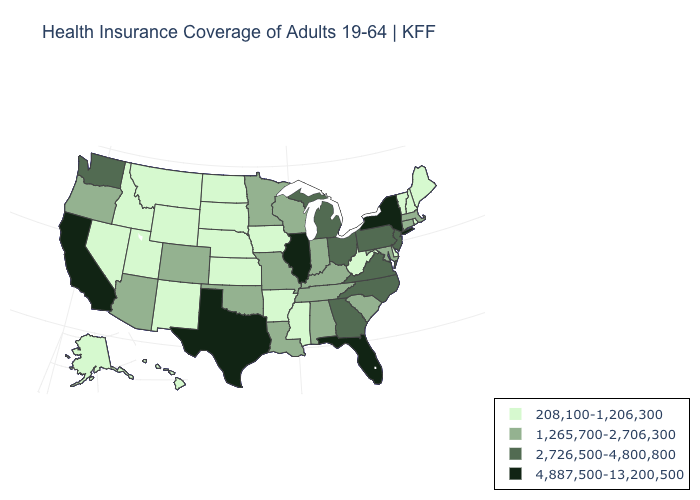Does Michigan have the same value as New Jersey?
Write a very short answer. Yes. What is the value of New Jersey?
Write a very short answer. 2,726,500-4,800,800. Name the states that have a value in the range 2,726,500-4,800,800?
Write a very short answer. Georgia, Michigan, New Jersey, North Carolina, Ohio, Pennsylvania, Virginia, Washington. Among the states that border Kentucky , does Virginia have the lowest value?
Be succinct. No. What is the lowest value in the MidWest?
Write a very short answer. 208,100-1,206,300. Does Texas have the highest value in the South?
Write a very short answer. Yes. Name the states that have a value in the range 4,887,500-13,200,500?
Keep it brief. California, Florida, Illinois, New York, Texas. Does Alaska have a lower value than Kentucky?
Answer briefly. Yes. Name the states that have a value in the range 4,887,500-13,200,500?
Answer briefly. California, Florida, Illinois, New York, Texas. Which states have the highest value in the USA?
Keep it brief. California, Florida, Illinois, New York, Texas. What is the value of South Carolina?
Keep it brief. 1,265,700-2,706,300. What is the value of Maryland?
Give a very brief answer. 1,265,700-2,706,300. What is the value of Michigan?
Answer briefly. 2,726,500-4,800,800. What is the value of Alabama?
Concise answer only. 1,265,700-2,706,300. What is the value of Oklahoma?
Concise answer only. 1,265,700-2,706,300. 